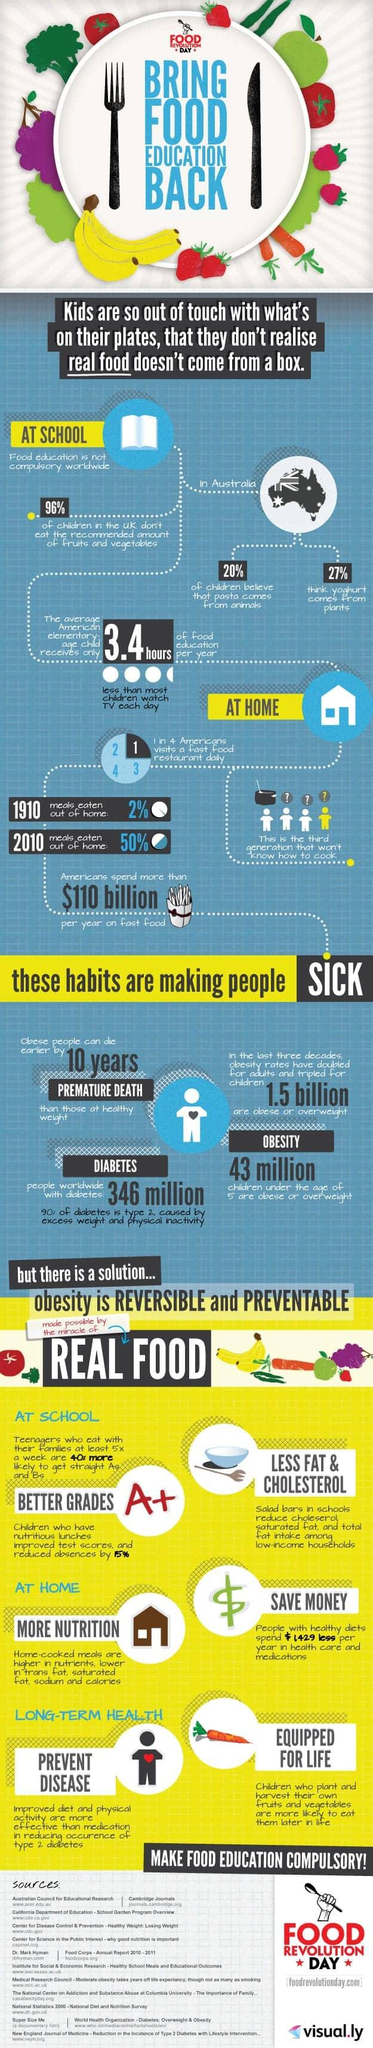Specify some key components in this picture. According to a recent survey conducted in Australia, it was revealed that two out of ten children believe that pasta comes from animals. According to a recent survey, approximately 25% of Americans visit a fast food restaurant on a daily basis. The amount of food education provided on television for children in America is significantly less than the amount of time that elementary age children spend watching TV. In the period between 1910 and 2010, there was a significant increase in the percentage of meals that were eaten out of the home, rising from 48% to 70%. 